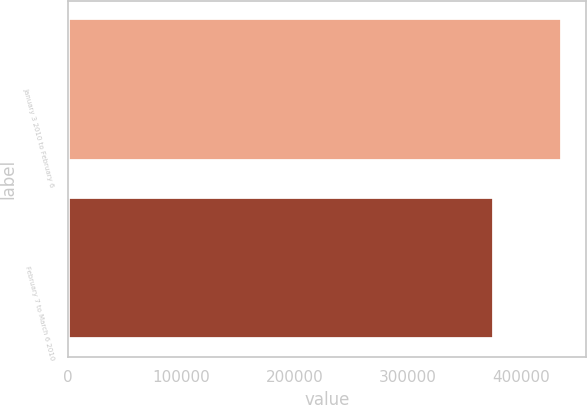Convert chart to OTSL. <chart><loc_0><loc_0><loc_500><loc_500><bar_chart><fcel>January 3 2010 to February 6<fcel>February 7 to March 6 2010<nl><fcel>435494<fcel>375709<nl></chart> 